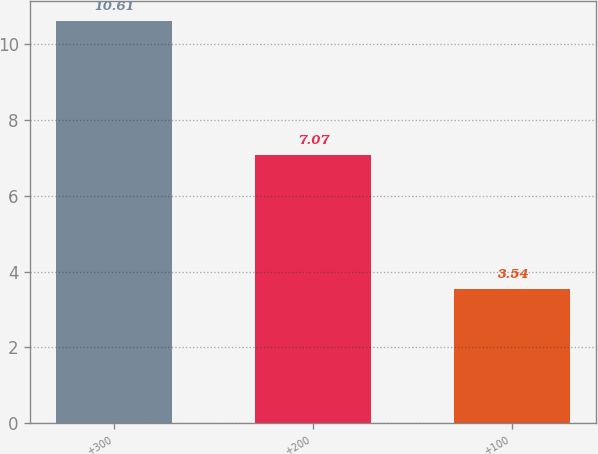Convert chart to OTSL. <chart><loc_0><loc_0><loc_500><loc_500><bar_chart><fcel>+300<fcel>+200<fcel>+100<nl><fcel>10.61<fcel>7.07<fcel>3.54<nl></chart> 